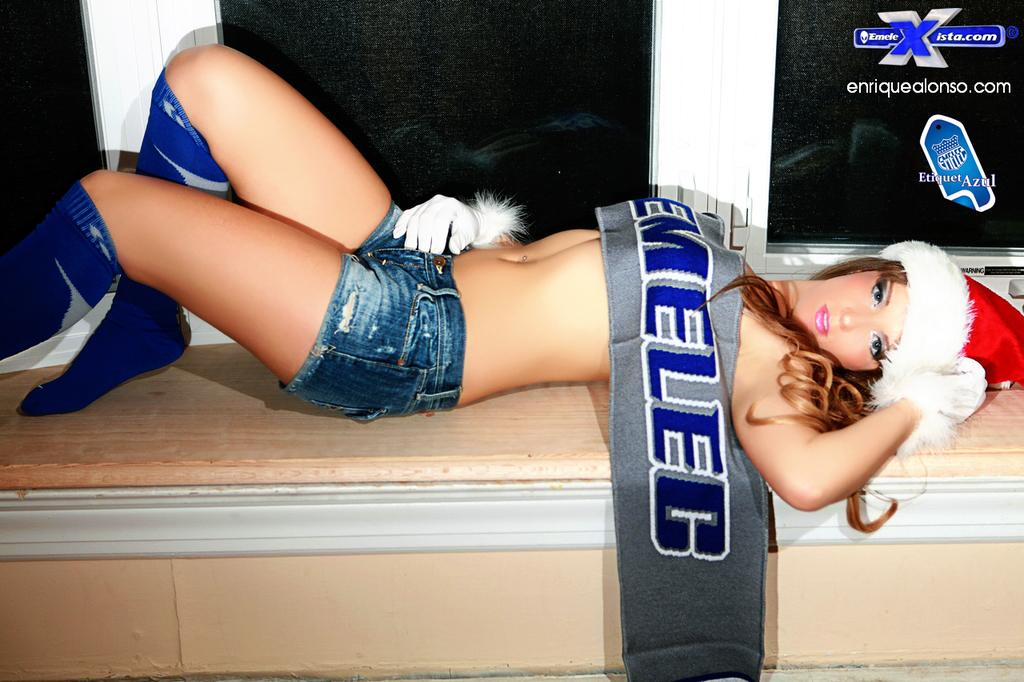<image>
Relay a brief, clear account of the picture shown. a model with a banner draped over her for enriquealonso.com 